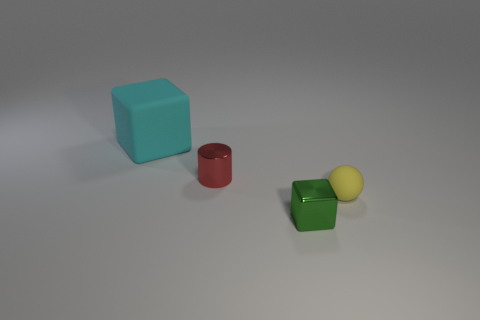Add 3 large red shiny balls. How many objects exist? 7 Subtract all balls. How many objects are left? 3 Add 1 big cyan things. How many big cyan things are left? 2 Add 1 big cyan matte things. How many big cyan matte things exist? 2 Subtract 1 green cubes. How many objects are left? 3 Subtract all tiny purple metal things. Subtract all large matte things. How many objects are left? 3 